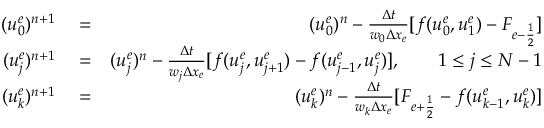<formula> <loc_0><loc_0><loc_500><loc_500>\begin{array} { r l r } { ( u _ { 0 } ^ { e } ) ^ { n + 1 } } & = } & { ( u _ { 0 } ^ { e } ) ^ { n } - \frac { \Delta t } { w _ { 0 } \Delta x _ { e } } [ f ( u _ { 0 } ^ { e } , u _ { 1 } ^ { e } ) - F _ { e - \frac { 1 } { 2 } } ] } \\ { ( u _ { j } ^ { e } ) ^ { n + 1 } } & = } & { ( u _ { j } ^ { e } ) ^ { n } - \frac { \Delta t } { w _ { j } \Delta x _ { e } } [ f ( u _ { j } ^ { e } , u _ { j + 1 } ^ { e } ) - f ( u _ { j - 1 } ^ { e } , u _ { j } ^ { e } ) ] , \quad 1 \leq j \leq N - 1 } \\ { ( u _ { k } ^ { e } ) ^ { n + 1 } } & = } & { ( u _ { k } ^ { e } ) ^ { n } - \frac { \Delta t } { w _ { k } \Delta x _ { e } } [ F _ { e + \frac { 1 } { 2 } } - f ( u _ { k - 1 } ^ { e } , u _ { k } ^ { e } ) ] } \end{array}</formula> 